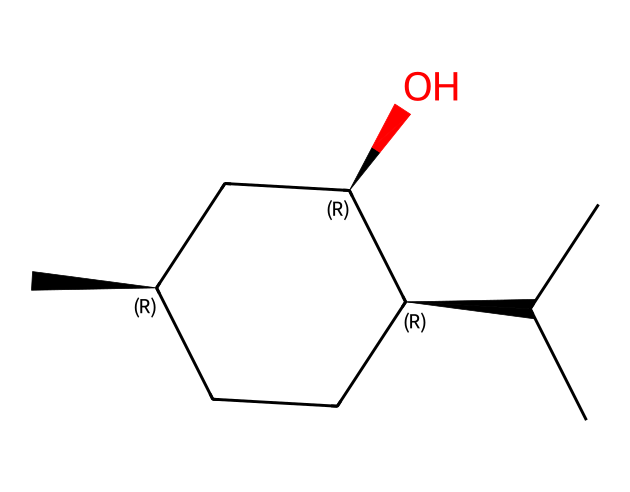What is the molecular formula of menthol? To derive the molecular formula, count the number of each type of atom in the SMILES representation. The chemical has 10 carbon (C) atoms, 20 hydrogen (H) atoms, and 1 oxygen (O) atom, resulting in the formula C10H20O.
Answer: C10H20O How many chiral centers are present in menthol? The structure indicates the presence of three chiral centers, which can be identified by locating the carbon atoms that have four different substituents. In this case, they correspond to three specific carbon atoms in the structure.
Answer: 3 What type of compound is menthol? Menthol is classified as a tertiary alcohol due to the presence of an -OH (hydroxyl) group attached to a carbon atom that is bonded to three other carbon atoms, indicating its functional category.
Answer: tertiary alcohol What is the significance of chirality in menthol? Chirality allows menthol to exist in multiple stereoisomeric forms, each potentially having different flavor, aroma, and physiological effects. This distinction is essential for its application in food, fragrance, and medicinal products.
Answer: different effects What is the saturation level of the carbon chain in menthol? The carbon chain contains only single bonds between carbon atoms, indicating that menthol is a saturated compound. No double or triple bonds are present in the structure, thus confirming saturation.
Answer: saturated 